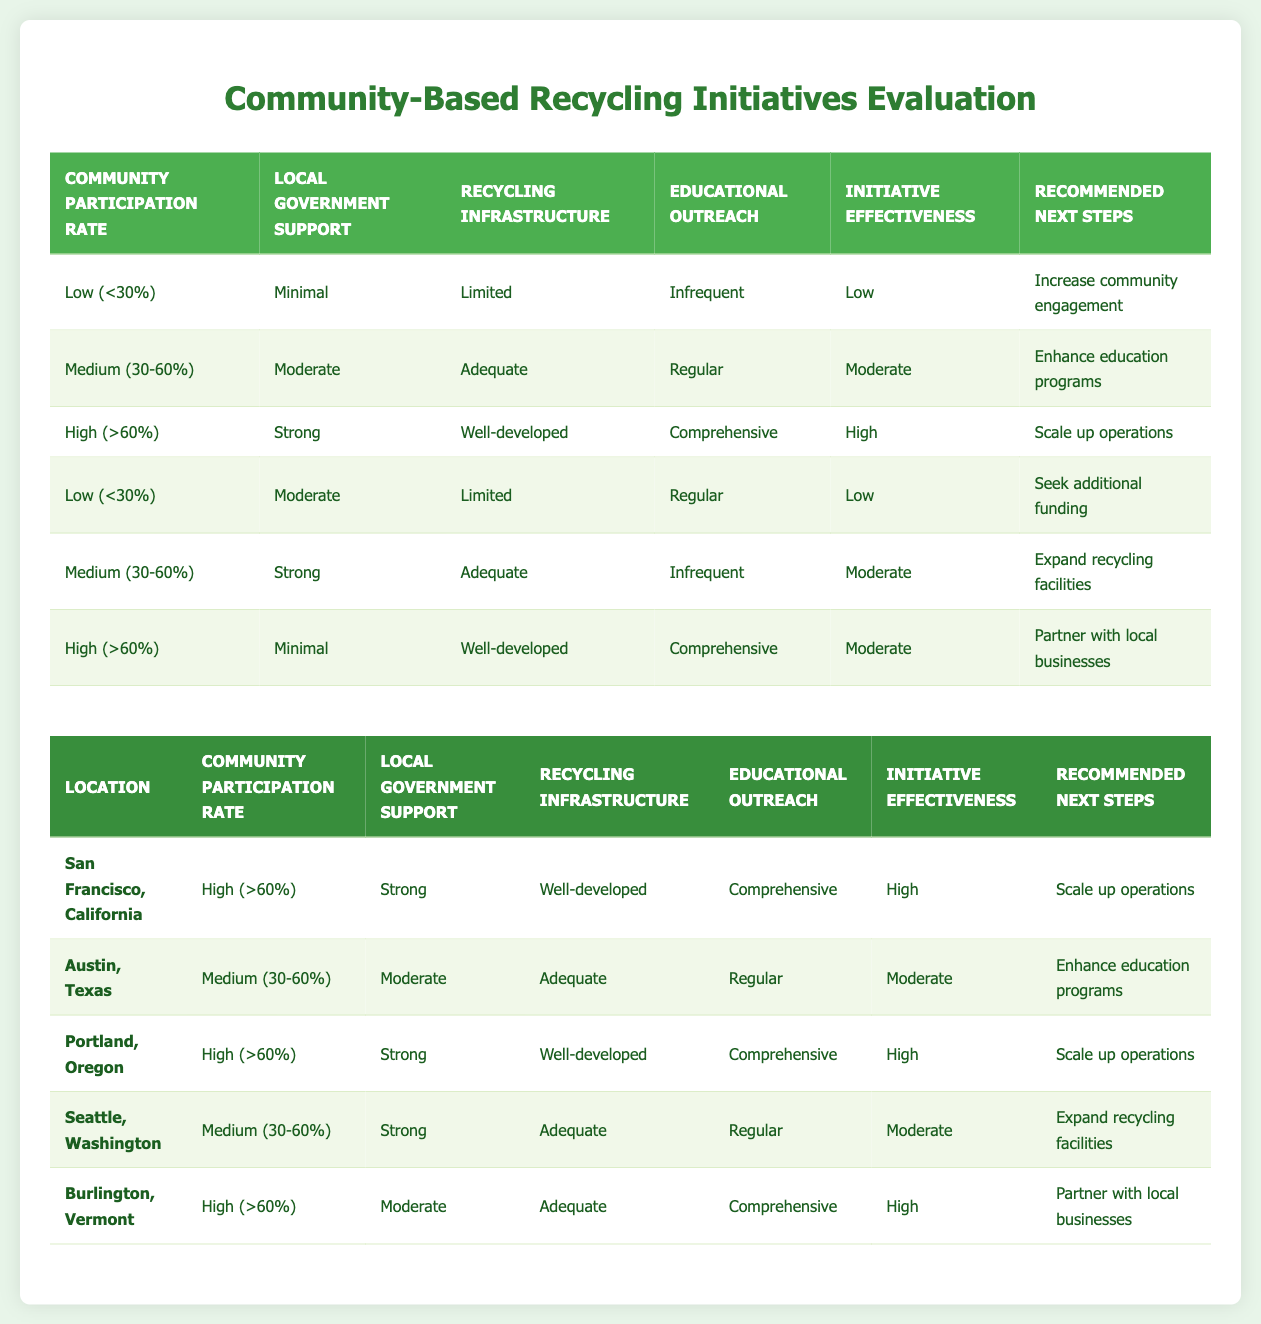What is the recommended next step for a community with low participation rate and minimal local government support? According to the table, a community with low participation rate (<30%), minimal local government support, limited recycling infrastructure, and infrequent educational outreach has a recommended next step of "Increase community engagement." This is explicitly stated in the first rule of the decision table.
Answer: Increase community engagement How many examples have a high initiative effectiveness? By looking at the highlighted examples, there are three locations: San Francisco, California; Portland, Oregon; and Burlington, Vermont that show a high initiative effectiveness.
Answer: 3 Is it true that all communities with a high participation rate also have strong local government support? No, this is not true. In the examples, Burlington, Vermont has a high participation rate (>60%) but moderate local government support. Therefore, not all high participation rate communities have strong local government support.
Answer: No What is the average initiative effectiveness rating for communities with strong local government support? From the examples, we can assess the initiative effectiveness for the communities with strong local government support: San Francisco (High), Portland (High), and Seattle (Moderate). The total effectiveness is 2 (High) + 2 (High) + 1 (Moderate) = 5. There are 3 communities, so the average is 5 / 3 = approximately 1.67, which can be roughly considered as moderate.
Answer: Moderate Which recommended next step is associated with a medium participation rate and strong local government support? According to the rule for medium participation rate (30-60%), strong local government support, adequate recycling infrastructure, and regular educational outreach, the recommended next step is to "Expand recycling facilities." This is derived from a clear association in the rules provided.
Answer: Expand recycling facilities How many examples have regular educational outreach? Looking at the highlighted examples, Austin, Texas, Seattle, Washington have regular educational outreach. Thus, there are two instances of regular educational outreach among the provided examples.
Answer: 2 What is the link between community participation rate and initiative effectiveness in the given examples? In the examples, a high community participation rate (>60%) corresponds to high initiative effectiveness (San Francisco and Portland). A medium participation rate (30-60%) results in moderate effectiveness (Austin and Seattle), while low participation rate (<30%) gives low effectiveness (as shown in the rules). This indicates a direct positive correlation between the two factors.
Answer: Positive correlation Do all locations with moderate initiative effectiveness have an adequate recycling infrastructure? No, not all locations with moderate initiative effectiveness have an adequate recycling infrastructure. For example, Seattle has a medium participation rate and moderate initiative effectiveness but has adequate recycling infrastructure. However, Austin, which also has moderate effectiveness, has an adequate recycling infrastructure. Thus, this statement is not universally true.
Answer: No 